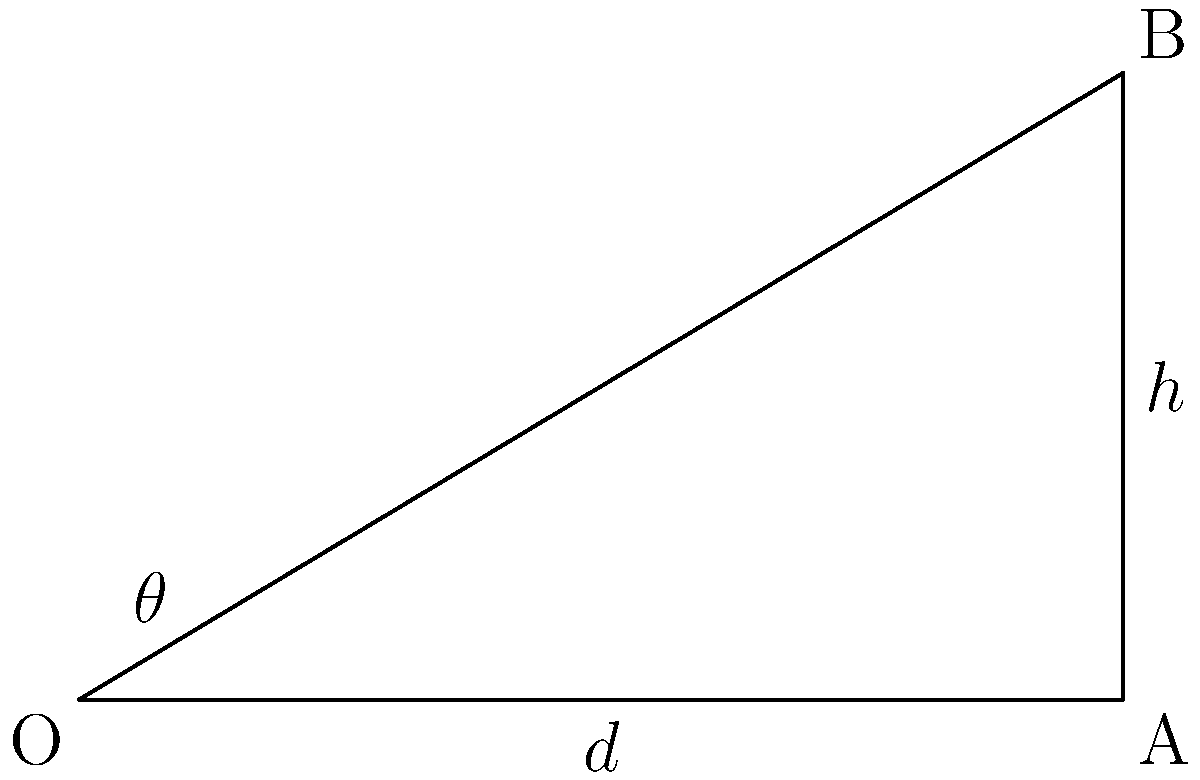During a crucial free kick, you notice the wall is positioned 5 meters away and the crossbar is 3 meters high. What angle $\theta$ should the player aim for to clear the wall and hit the top corner of the goal, assuming a straight trajectory? Round your answer to the nearest degree. To find the optimal angle $\theta$ for the free kick, we'll use trigonometry:

1) In the right triangle OAB:
   - The adjacent side (d) is 5 meters (distance to the wall)
   - The opposite side (h) is 3 meters (height of the crossbar)

2) We can use the tangent function to find $\theta$:

   $\tan(\theta) = \frac{\text{opposite}}{\text{adjacent}} = \frac{h}{d} = \frac{3}{5}$

3) To solve for $\theta$, we use the inverse tangent (arctangent) function:

   $\theta = \arctan(\frac{3}{5})$

4) Using a calculator or trigonometric tables:

   $\theta \approx 30.9638°$

5) Rounding to the nearest degree:

   $\theta \approx 31°$
Answer: 31° 